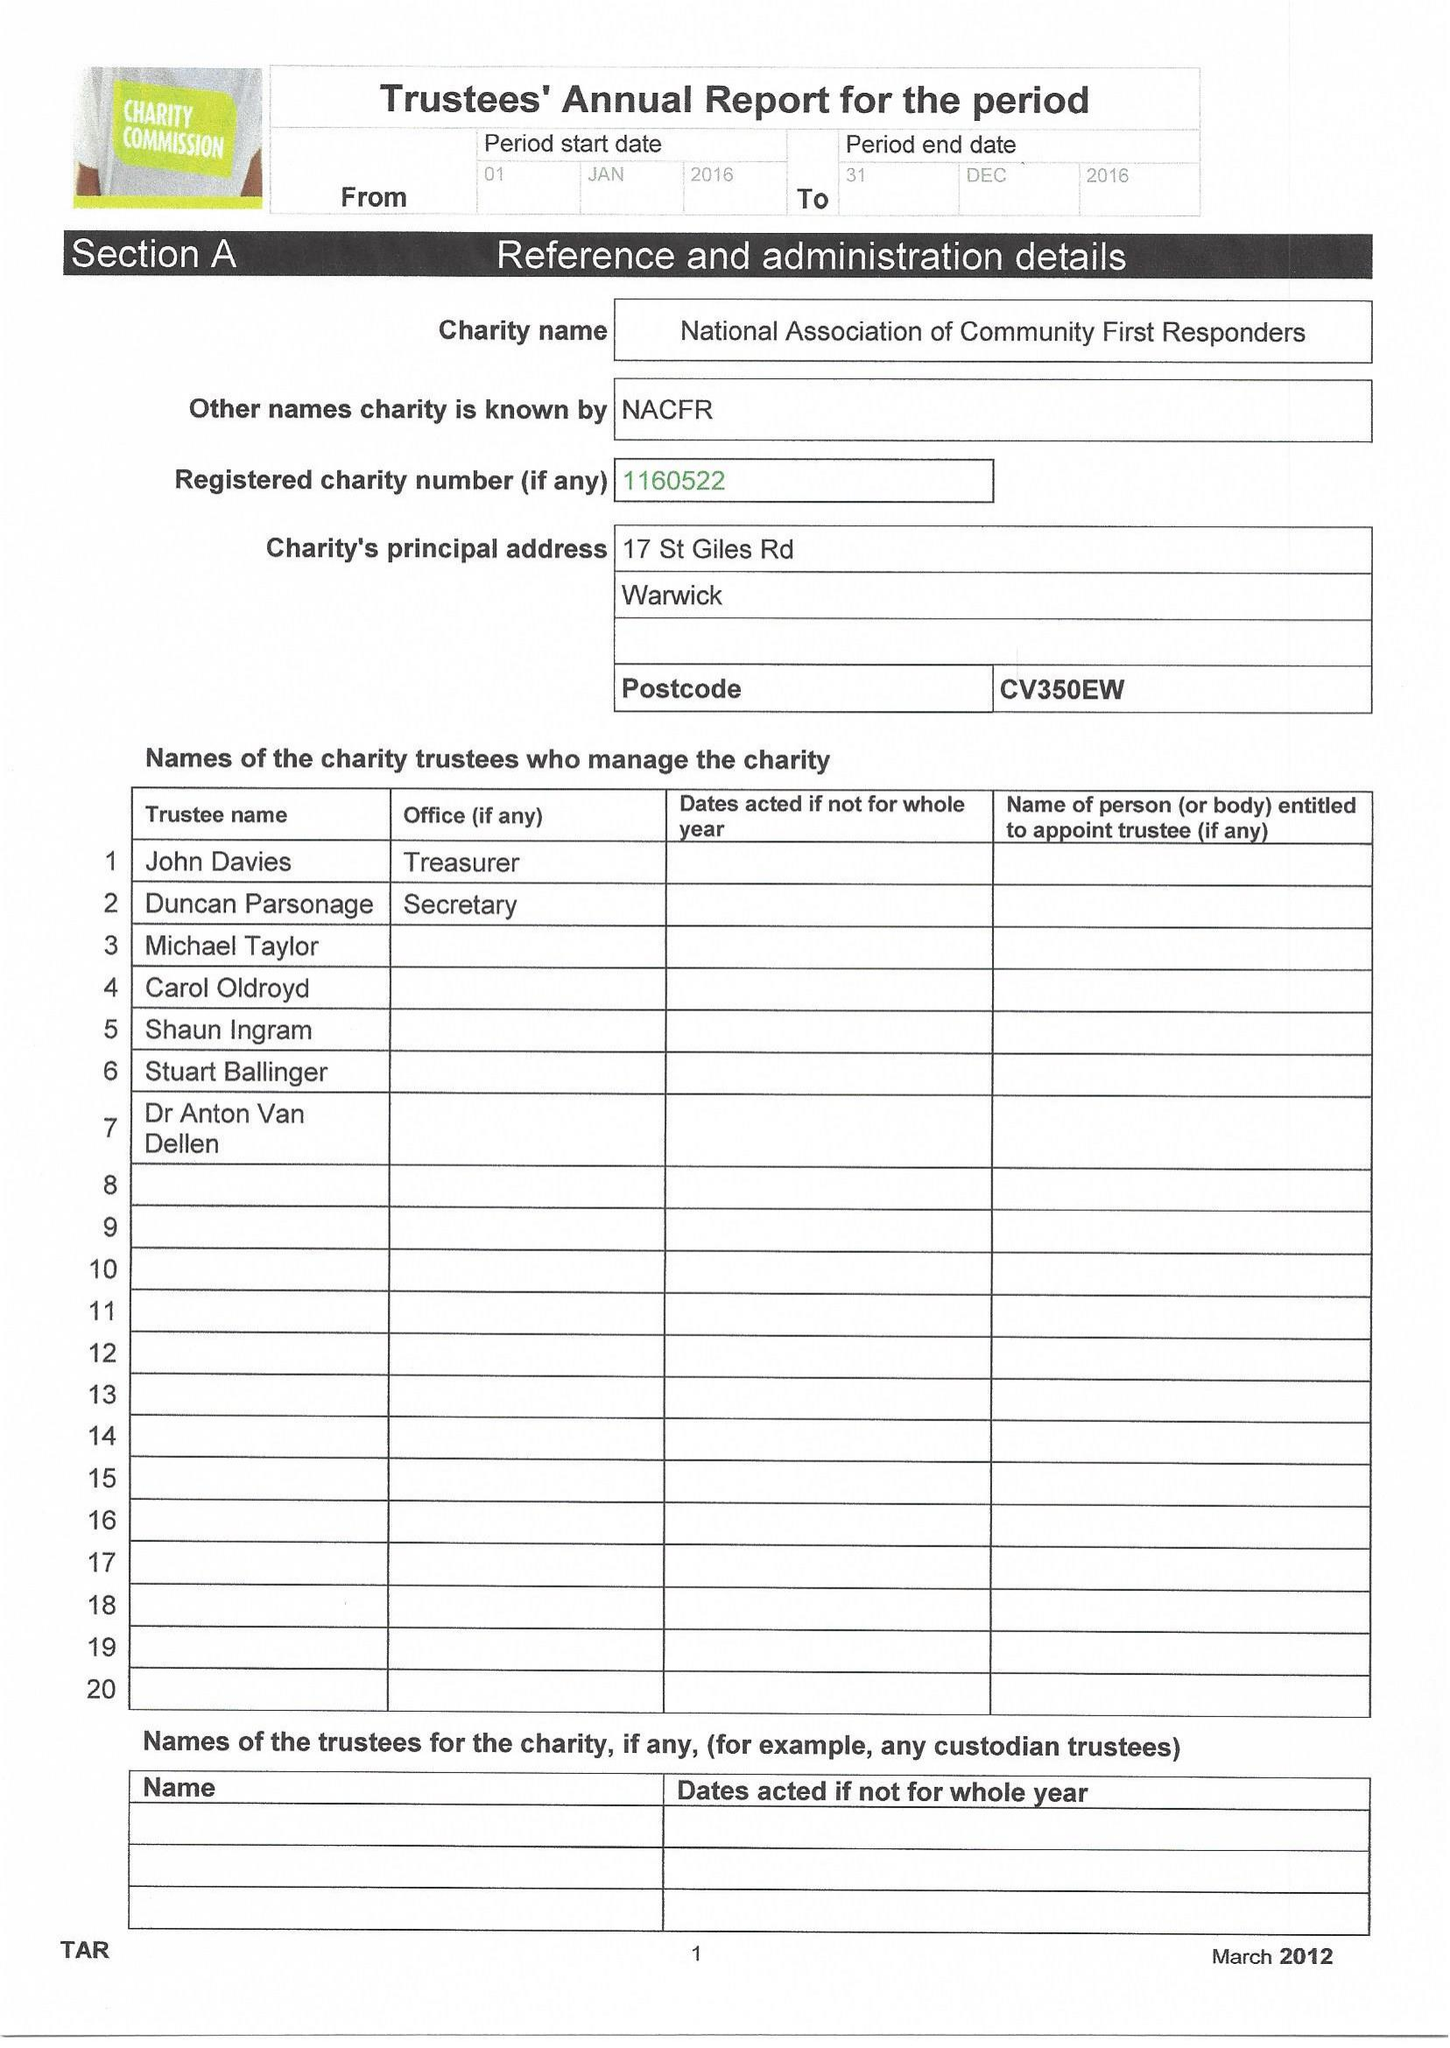What is the value for the income_annually_in_british_pounds?
Answer the question using a single word or phrase. 100.00 